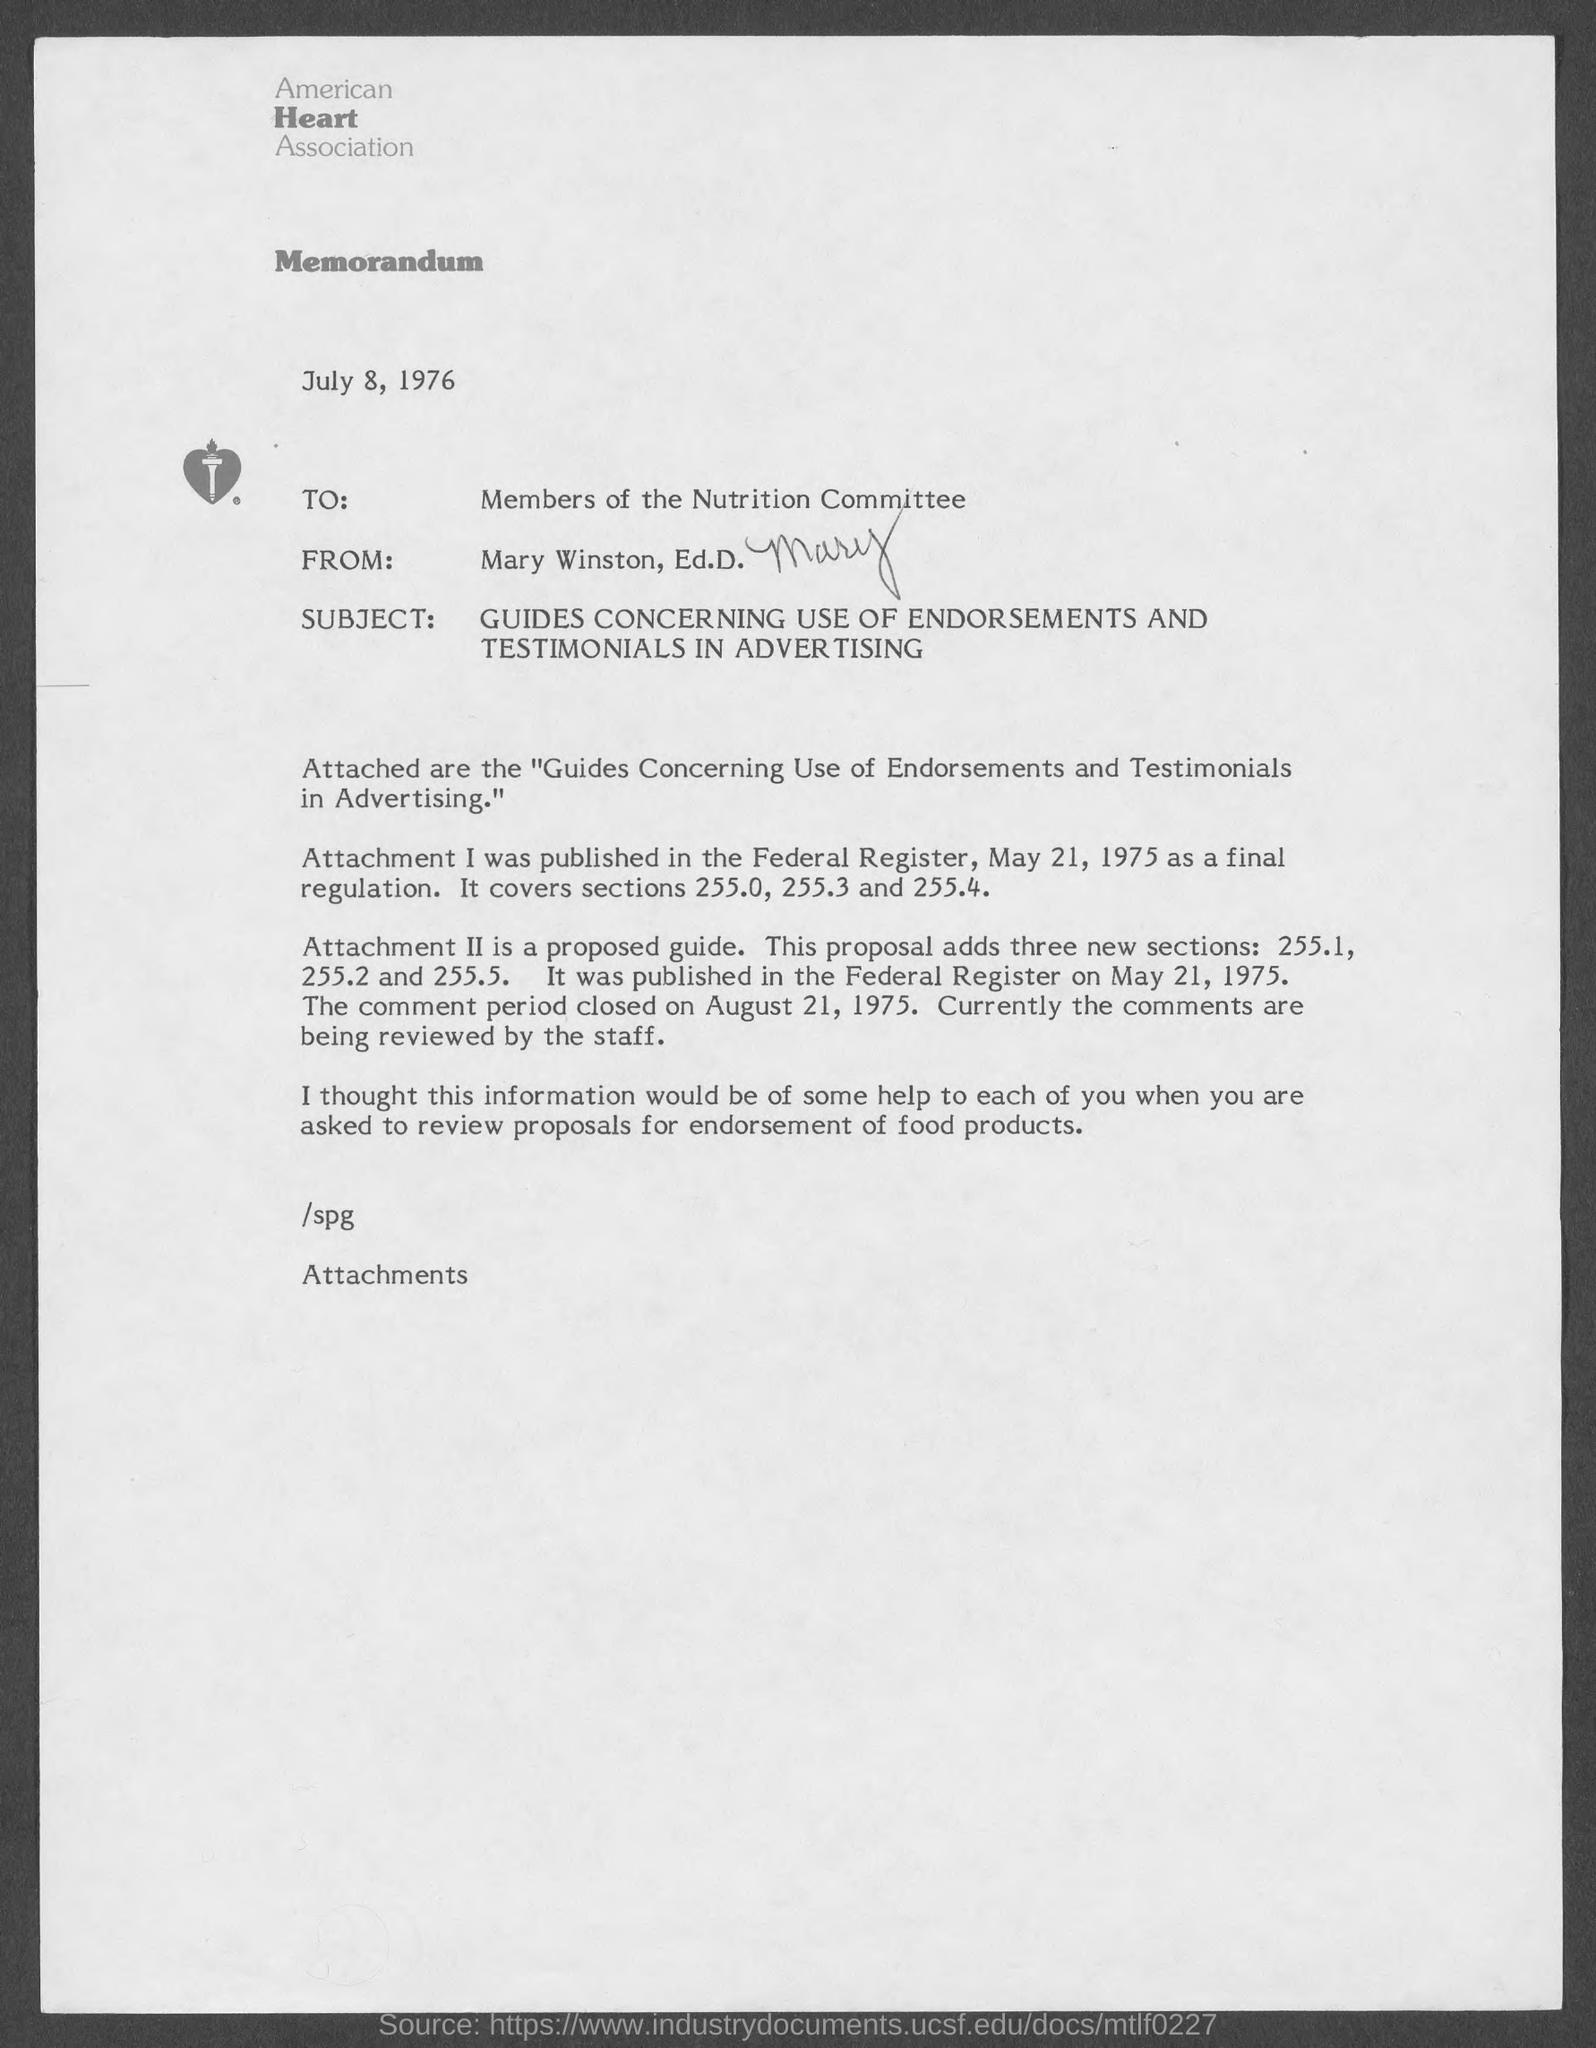List a handful of essential elements in this visual. The letter is from Mary Winston. The date on the document is July 8, 1976. The Federal Register was the publication location for attachment 1. 